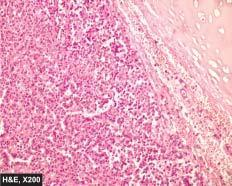does the show a characteristic nested of cells separated by fibrovascular septa?
Answer the question using a single word or phrase. No 